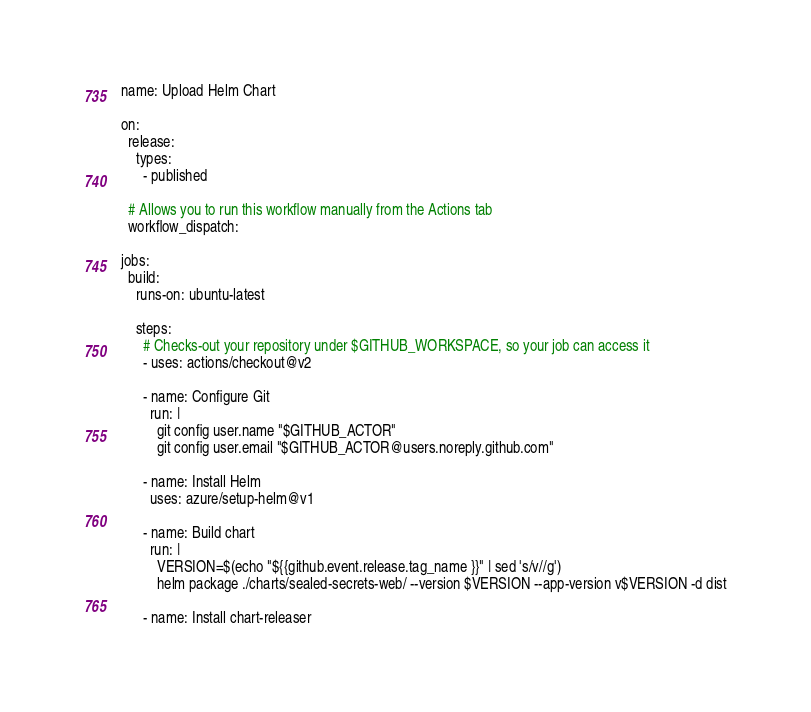<code> <loc_0><loc_0><loc_500><loc_500><_YAML_>name: Upload Helm Chart

on:
  release:
    types:
      - published

  # Allows you to run this workflow manually from the Actions tab
  workflow_dispatch:

jobs:
  build:
    runs-on: ubuntu-latest

    steps:
      # Checks-out your repository under $GITHUB_WORKSPACE, so your job can access it
      - uses: actions/checkout@v2

      - name: Configure Git
        run: |
          git config user.name "$GITHUB_ACTOR"
          git config user.email "$GITHUB_ACTOR@users.noreply.github.com"

      - name: Install Helm
        uses: azure/setup-helm@v1

      - name: Build chart
        run: |
          VERSION=$(echo "${{github.event.release.tag_name }}" | sed 's/v//g')
          helm package ./charts/sealed-secrets-web/ --version $VERSION --app-version v$VERSION -d dist

      - name: Install chart-releaser</code> 